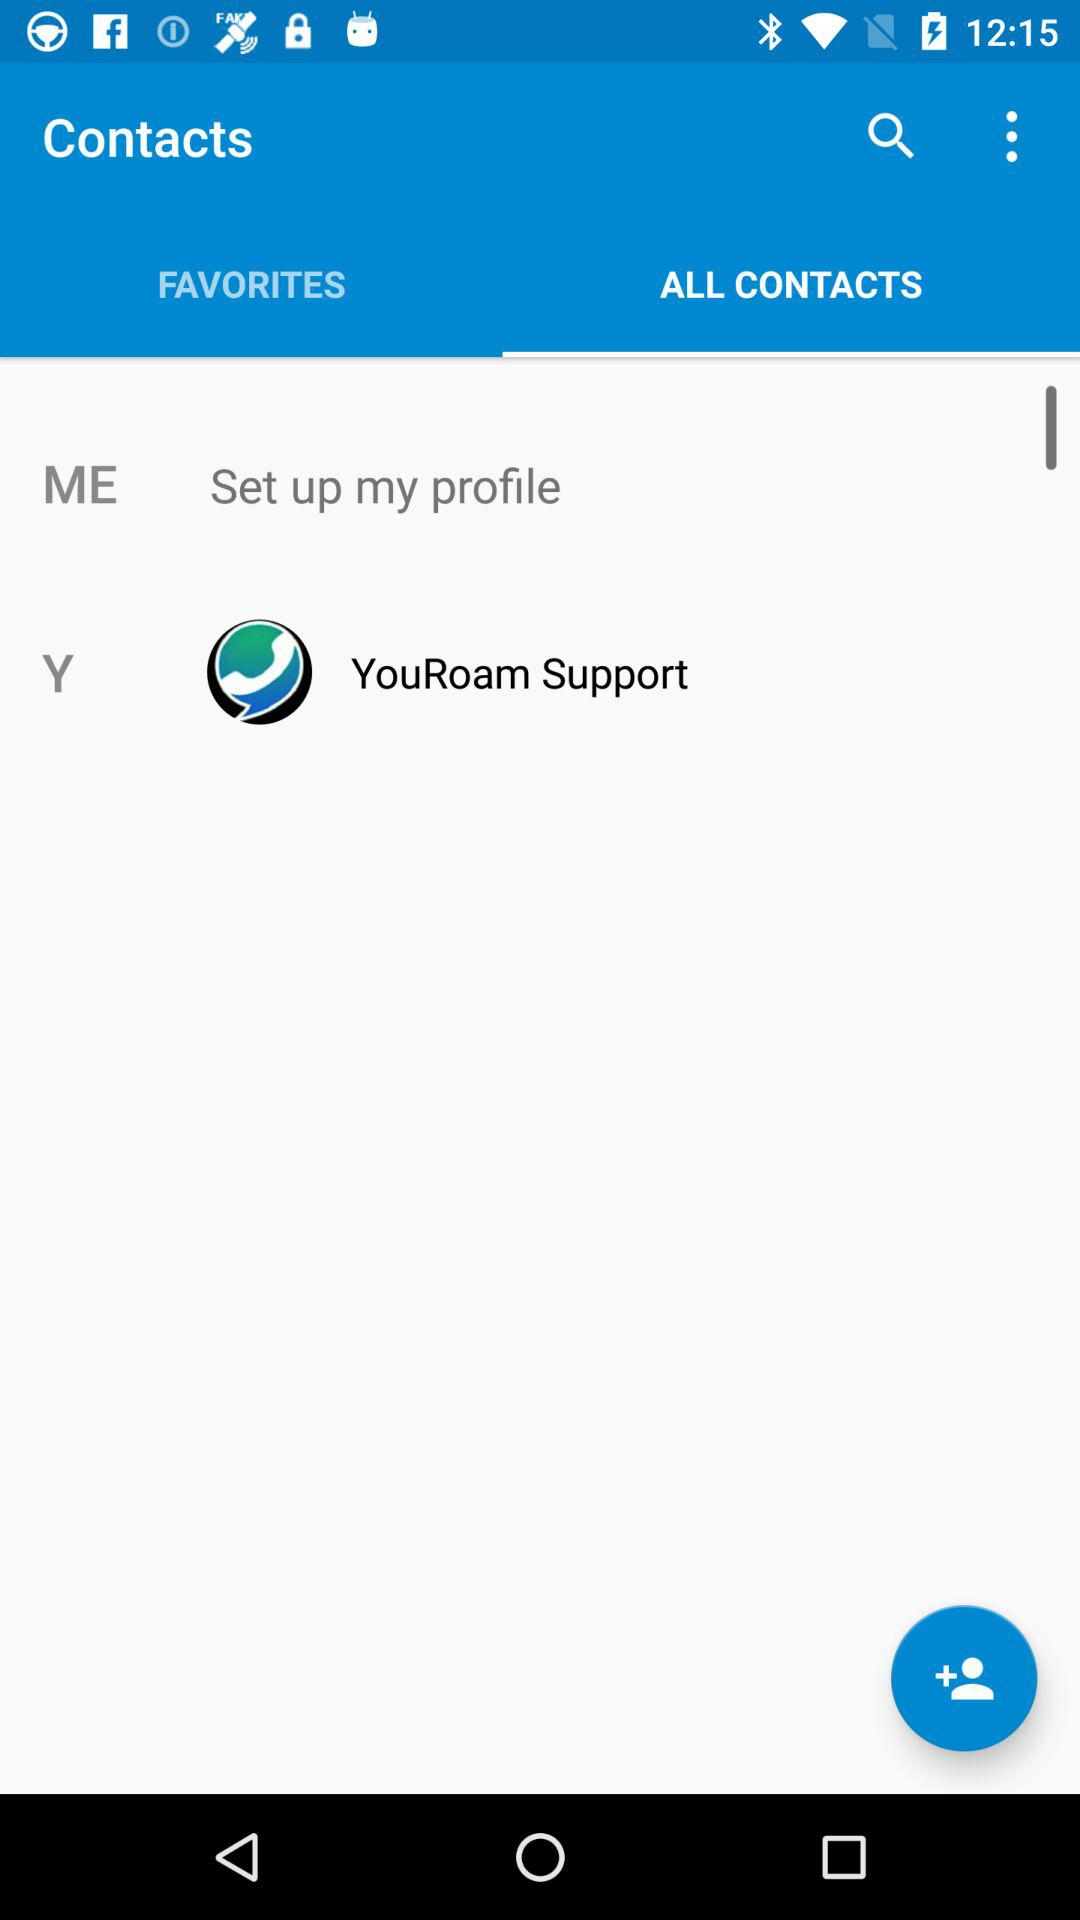Which option is selected? The selected option is "ALL CONTACTS". 